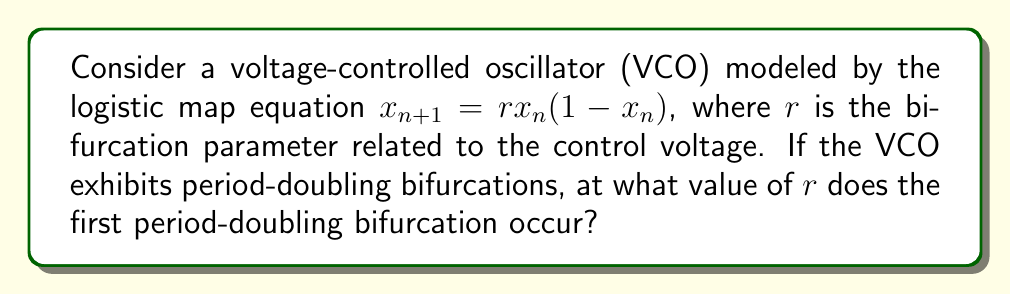Solve this math problem. To find the first period-doubling bifurcation point in the logistic map, we need to follow these steps:

1) In the logistic map, the fixed points are given by the equation:
   $x^* = rx^*(1-x^*)$

2) Solving this equation, we get two fixed points:
   $x^*_1 = 0$ and $x^*_2 = 1 - \frac{1}{r}$

3) The stability of these fixed points is determined by the derivative of the map at the fixed point. The fixed point is stable if $|\frac{df}{dx}| < 1$ at $x^*$.

4) The derivative of the logistic map is:
   $\frac{df}{dx} = r(1-2x)$

5) For the non-zero fixed point $x^*_2 = 1 - \frac{1}{r}$, the derivative is:
   $\frac{df}{dx}|_{x^*_2} = r(1-2(1-\frac{1}{r})) = r(2\frac{1}{r}-1) = 2-r$

6) The period-doubling bifurcation occurs when this derivative equals -1:
   $2-r = -1$

7) Solving this equation:
   $r = 3$

Therefore, the first period-doubling bifurcation in the logistic map occurs at $r=3$. This is the point where the VCO's behavior would change from a single stable oscillation to an alternation between two states.
Answer: $r = 3$ 